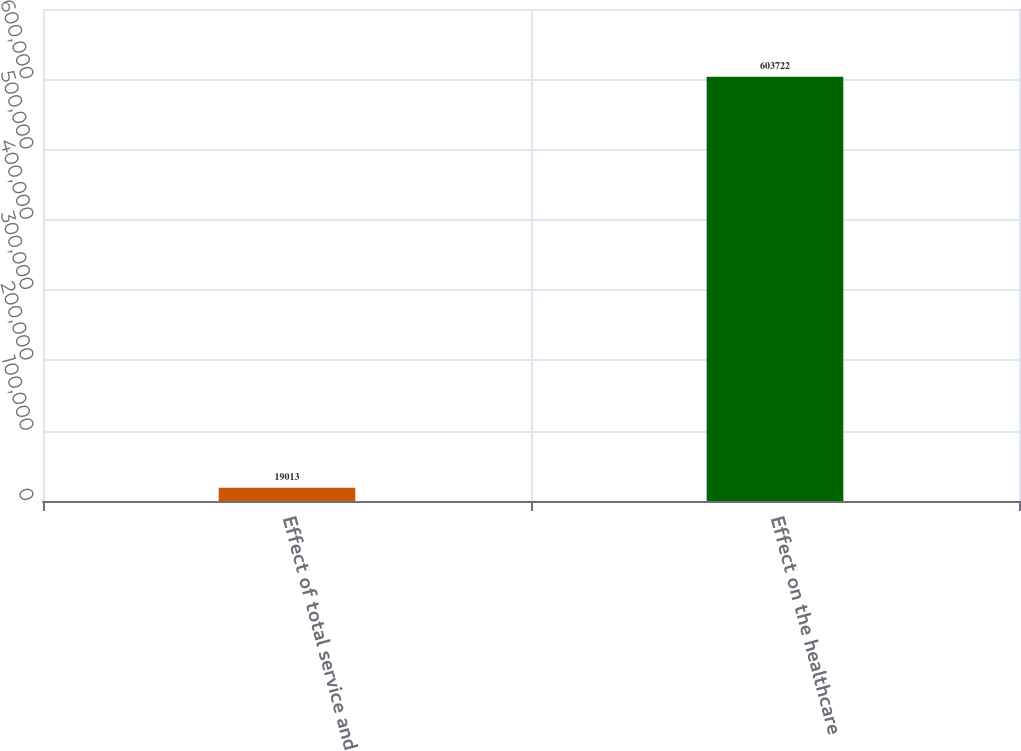Convert chart. <chart><loc_0><loc_0><loc_500><loc_500><bar_chart><fcel>Effect of total service and<fcel>Effect on the healthcare<nl><fcel>19013<fcel>603722<nl></chart> 